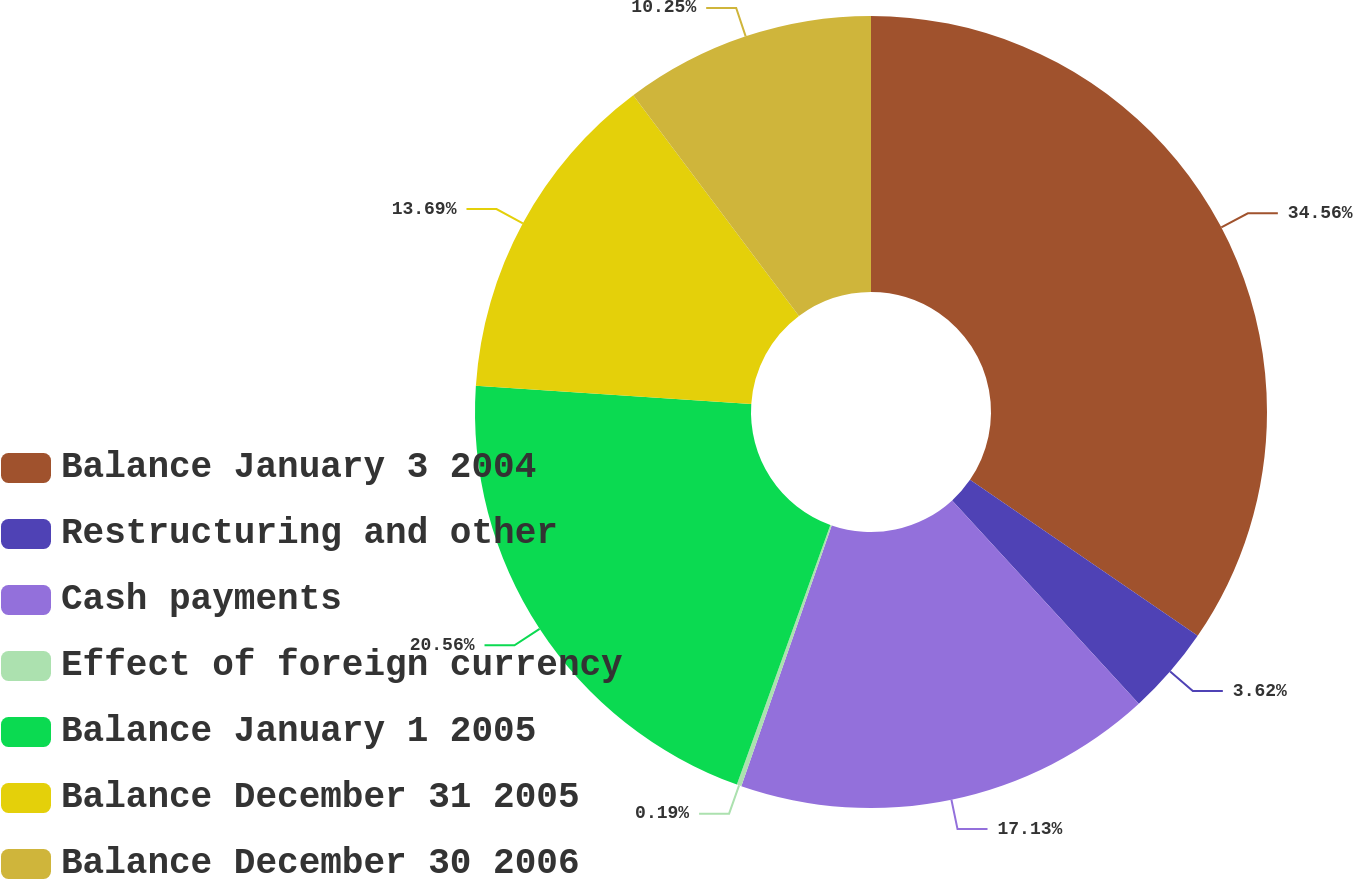Convert chart. <chart><loc_0><loc_0><loc_500><loc_500><pie_chart><fcel>Balance January 3 2004<fcel>Restructuring and other<fcel>Cash payments<fcel>Effect of foreign currency<fcel>Balance January 1 2005<fcel>Balance December 31 2005<fcel>Balance December 30 2006<nl><fcel>34.56%<fcel>3.62%<fcel>17.13%<fcel>0.19%<fcel>20.56%<fcel>13.69%<fcel>10.25%<nl></chart> 